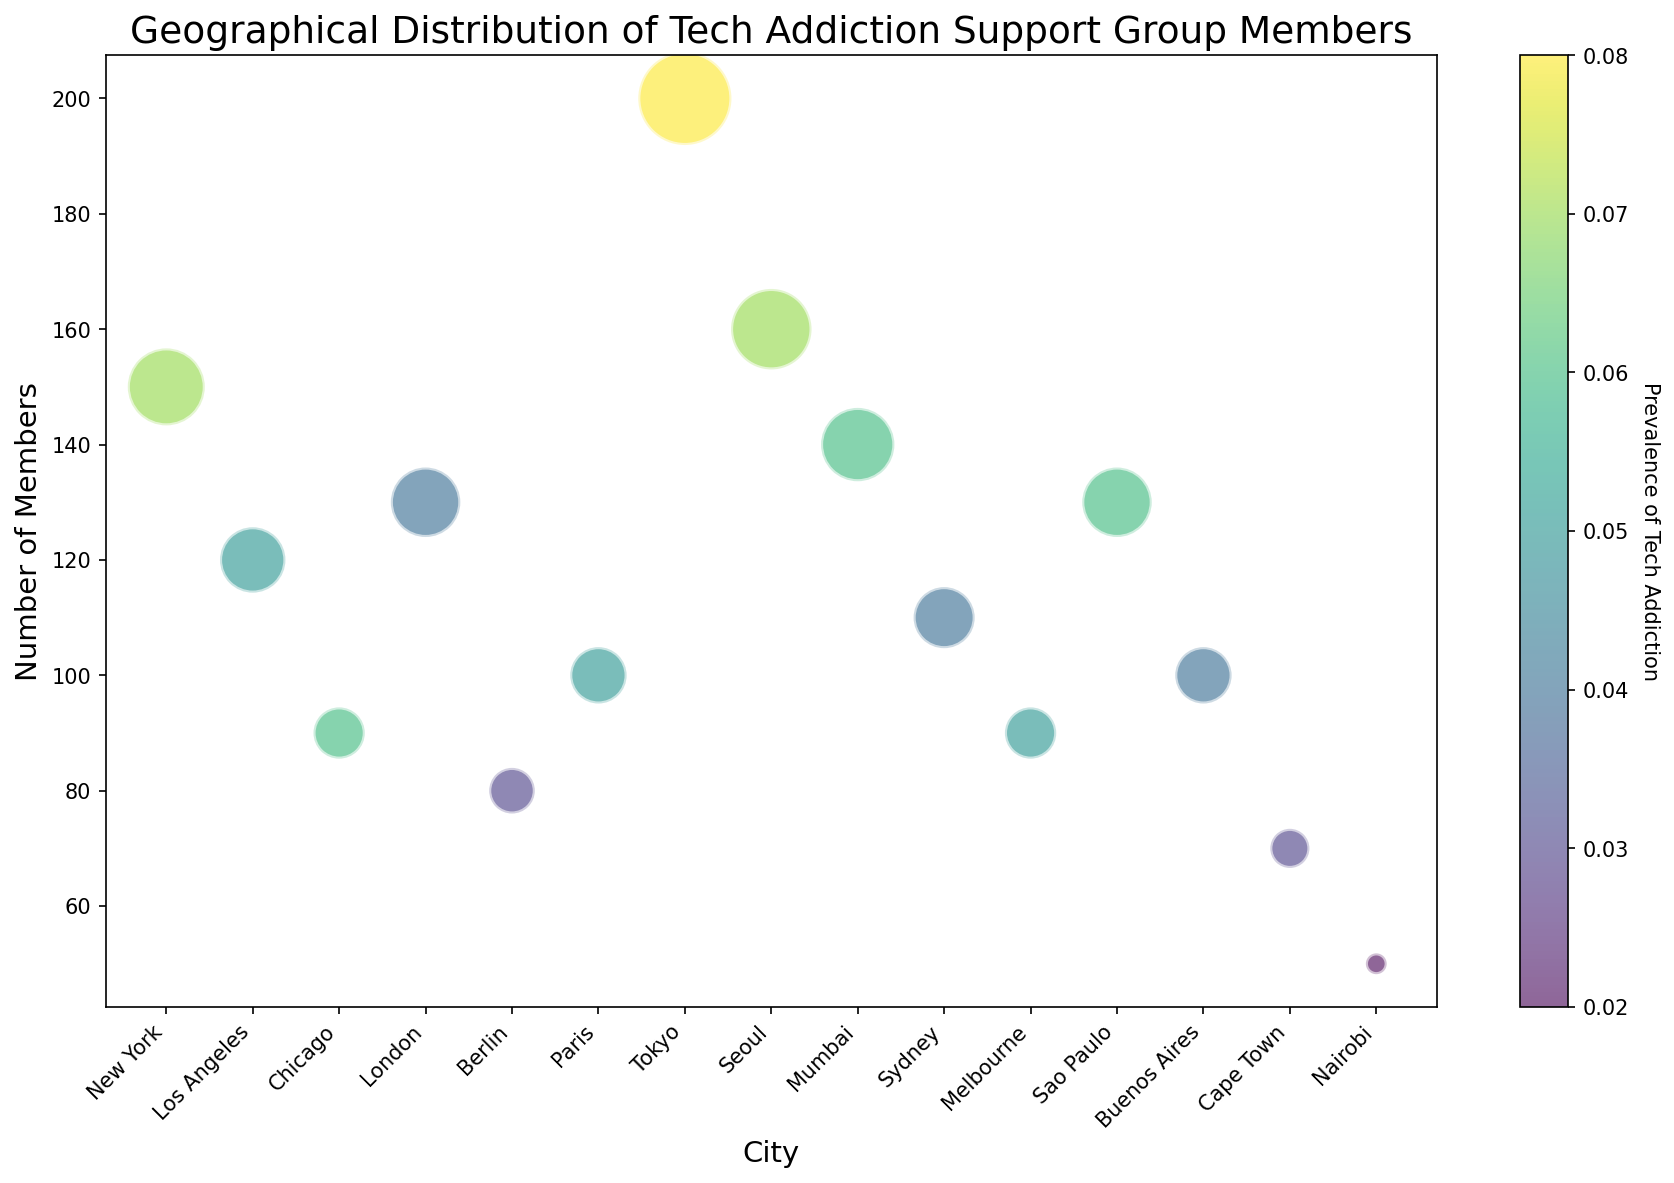What's the largest bubble on the chart? The size of the bubbles in the chart represents the number of members in each city. The largest bubble corresponds to Tokyo, which has the highest number of members, 200.
Answer: Tokyo Which city has the lowest prevalence of tech addiction? The color of the bubbles indicates the prevalence of tech addiction. The bubble with the lightest color represents the lowest prevalence. Nairobi has the lightest color and hence the lowest prevalence of tech addiction, 0.02.
Answer: Nairobi How do the sizes of the bubbles for New York and Tokyo compare? The size of the bubbles represents the number of members. Tokyo has 200 members, and New York has 150 members. Tokyo's bubble should be larger than New York's bubble.
Answer: Tokyo's bubble is larger than New York's bubble Which region has the most cities represented in the chart? The figure shows the cities grouped by regions. North America and Asia each have 3 cities represented (New York, Los Angeles, Chicago for North America and Tokyo, Seoul, Mumbai for Asia). Other regions have fewer cities represented.
Answer: North America and Asia What is the average number of members in the European cities presented? To find the average number of members in European cities, sum the number of members in London (130), Berlin (80), and Paris (100), and then divide by the number of cities (3). (130 + 80 + 100) / 3 = 103.33.
Answer: 103.33 Compare the cities with the highest prevalence of tech addiction in Asia and in Europe. In Asia, Tokyo has the highest prevalence of 0.08. In Europe, Paris has the highest prevalence of 0.05. Tokyo's prevalence is greater than Paris's prevalence.
Answer: Tokyo's prevalence is greater than Paris's Which two cities have the same prevalence of tech addiction but from different regions? The color representing prevalence indicates that both Chicago (North America) and Mumbai (Asia) have a prevalence of 0.06.
Answer: Chicago and Mumbai Which region has a wider range of bubble sizes, North America or Europe? North America has cities with 150, 120, and 90 members, while Europe has cities with 130, 80, and 100 members. The range for North America is 150 - 90 = 60, and the range for Europe is 130 - 80 = 50. North America has a wider range of bubble sizes.
Answer: North America What are the colors of the bubbles indicating the highest and lowest tech addiction prevalence? The highest prevalence (0.08) is in Tokyo, and it shows a darker color (closer to the upper end of the color bar). The lowest prevalence (0.02) is in Nairobi, shown with a lighter color (closer to the lower end of the color bar).
Answer: Darker for highest, lighter for lowest 